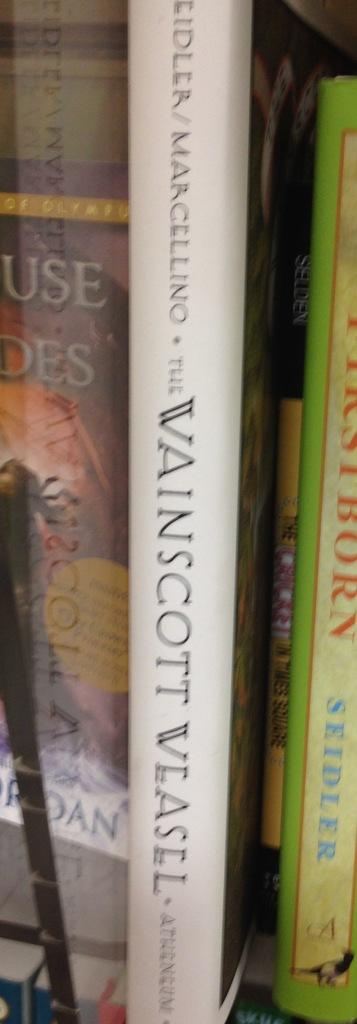What is the white book called?
Offer a very short reply. Wainscott weasel. What is the last name of the author of the white book?
Your response must be concise. Marcellino. 